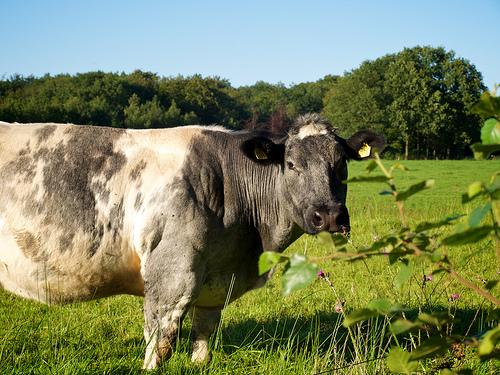Identify the type of flowers present in the image and their color. There are small pink flowers and some purple buds on a bush in the image. Identify the different elements sky in the photograph. The sky in the photograph is light blue, clear of clouds, and above the grassy field and row of trees. What kind of animal is the central focus of the image and what is its position? The central focus of the image is a cow standing in a grassy meadow and looking at the camera. Briefly describe the landscape in the image. The landscape includes a grassy field with a cow, bright green grass, small pink flowers, tall leaves of grass, and a row of trees in the background. Mention the unique features found on the cow's face. The cow's face has a white spot on the forehead, large round nostrils, and yellow tags in its ears. What are the main colors of the cow in the image and what are some distinct features? The cow has black and white fur with a large black patch on its back, grey markings across its back, and a white spot on its forehead. Comment on the appearance of the cow and its surrounding environment. The cow appears to be quite large and up in age, standing in a bright green grassy field with a clear light blue sky above and a row of large trees in the background. What type of plants can be found growing close to the cow? Tall stems with leaves and purple buds, plants with small pink flowers, and tall leaves of grass can be found close to the cow. What color is the sky in the image and are there any clouds? The sky is light blue in color and it is clear of clouds. Describe the immediate area around the feet of the cow. The immediate area around the feet of the cow has bright green grass and small pink flowers growing in the field. Observe the little pond surrounded by rocks and small plants at the bottom right corner of the image. Can you identify any fish swimming in the pond? This instruction is misleading because there is no mention of a pond, rocks, or fish in the image captions. The image seemingly focuses on a cow and other elements in a grassy field. A tractor is partially visible behind the row of trees. Describe the color and model of the tractor based on what you can see. This instruction is misleading because there is no mention of a tractor in the image captions. The image appears to show a pastoral scene with a cow, grass, trees, and flowers, but no machinery. You might notice an old barn structure in the background, with faded red paint and a rusty roof. What other details do you see on the barn? This instruction is misleading because there is no mention of a barn in the image captions. The background seems to consist of trees, grass, and the sky. Can you find the flock of birds flying in the sky? They have different shades of blue and appear to be heading south. This instruction is misleading because there is no mention of birds in the image captions. The image seemingly focuses on a cow in a field, grass, trees, and a clear blue sky. Spot a family of rabbits hiding beneath the leaves of the bush with small purple flowers. How many rabbits do you see, and what are they doing? This instruction is misleading because there is no mention of rabbits in the image captions. The image seems to be a pastoral scene with a cow, grass, trees, flowers, and other plants, but no wildlife. 